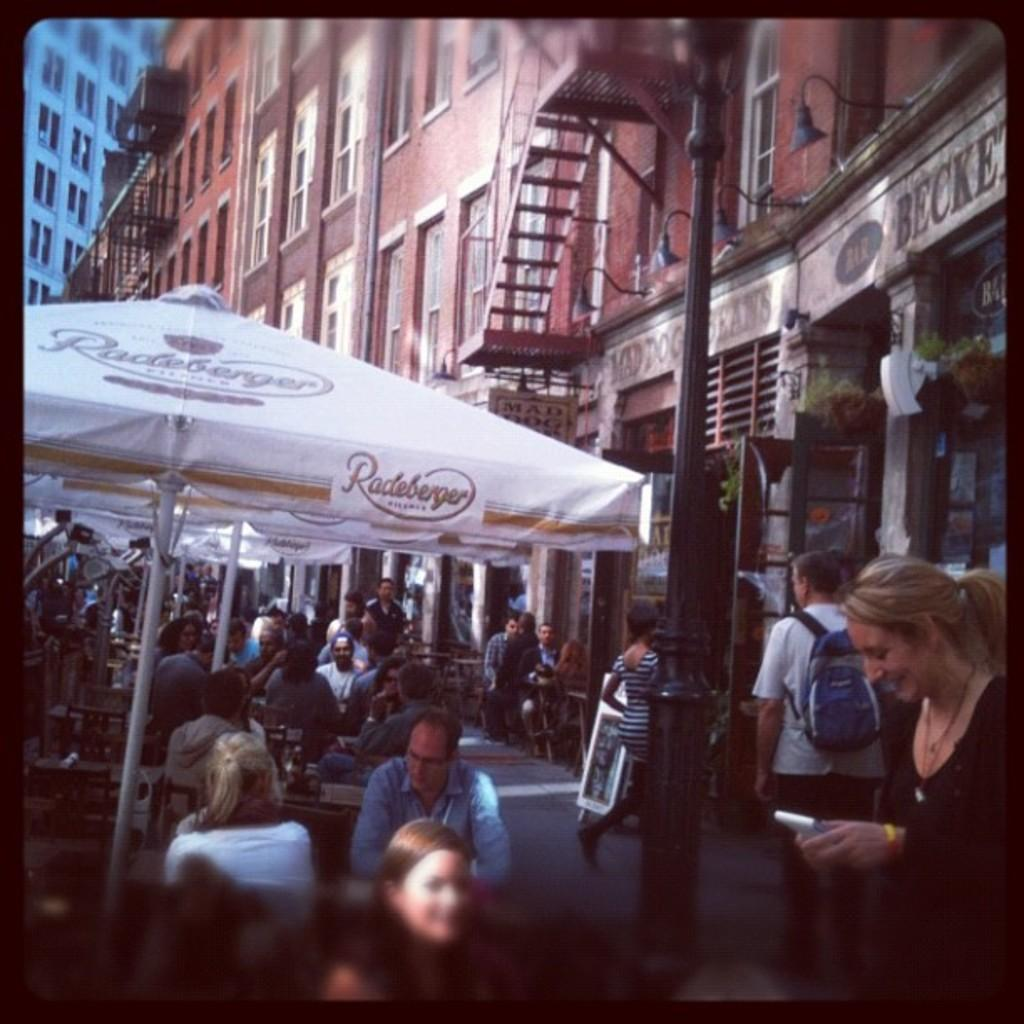What is happening on the road in the image? There are many people on the road in the image. What objects are being used by the people in the image? There are umbrellas in the image. What can be seen in the distance in the image? There are buildings in the background of the image. What type of bells can be heard ringing in the image? There are no bells present in the image, so it is not possible to hear them ringing. 